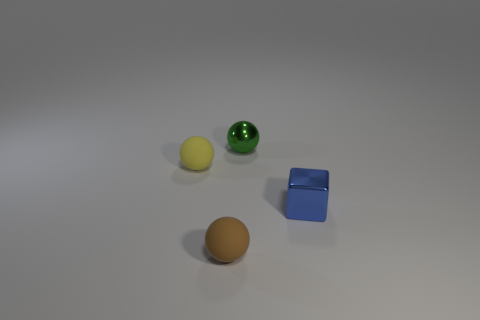Is the size of the brown matte ball the same as the sphere to the left of the brown rubber ball?
Ensure brevity in your answer.  Yes. Is there a blue cube behind the rubber sphere in front of the small yellow rubber thing?
Your answer should be compact. Yes. There is a tiny object that is right of the tiny metal sphere; what shape is it?
Your response must be concise. Cube. What is the color of the object behind the rubber sphere that is behind the blue metallic block?
Provide a short and direct response. Green. Do the yellow sphere and the green metal thing have the same size?
Offer a terse response. Yes. There is a tiny yellow thing that is the same shape as the tiny brown object; what is its material?
Keep it short and to the point. Rubber. What number of balls are the same size as the brown rubber thing?
Ensure brevity in your answer.  2. What color is the small cube that is made of the same material as the tiny green sphere?
Ensure brevity in your answer.  Blue. Is the number of big yellow metal blocks less than the number of blue metal cubes?
Make the answer very short. Yes. How many green objects are either metallic cylinders or shiny blocks?
Your answer should be very brief. 0. 